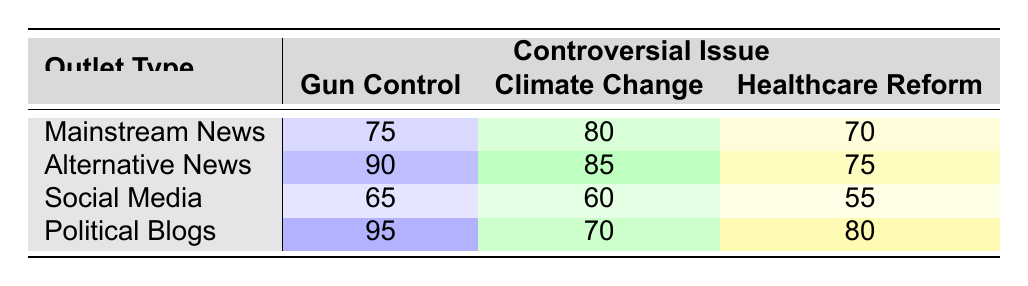What is the Coverage Score for Gun Control in Mainstream News? The table shows that the Coverage Score for Gun Control under Mainstream News is directly indicated in the first row under that column. The value is 75.
Answer: 75 Which outlet type has the highest Coverage Score for Climate Change? By examining the scores in the Climate Change column across all outlet types, Alternative News has the highest score of 85, as listed in the second row.
Answer: Alternative News What is the average Coverage Score for Healthcare Reform across all outlet types? To find the average Coverage Score for Healthcare Reform, we first sum the scores: (70 + 75 + 55 + 80) = 280. There are four outlet types, so we divide by 4: 280 / 4 = 70.
Answer: 70 True or False: Political Blogs gave a higher Coverage Score for Gun Control compared to Social Media. Looking at the table, the Coverage Score for Gun Control in Political Blogs is 95, while it is 65 for Social Media. Since 95 > 65, the statement is true.
Answer: True Which outlet type shows the least Coverage Score for Climate Change? By reviewing the scores for Climate Change, Social Media has the lowest score of 60, as seen in the last row.
Answer: Social Media What is the difference between the Coverage Scores for Gun Control in Political Blogs and Mainstream News? The Coverage Score for Gun Control in Political Blogs is 95, while it is 75 in Mainstream News. The difference is calculated as 95 - 75 = 20.
Answer: 20 Is the Coverage Score for Healthcare Reform in Alternative News higher than that in Mainstream News? The Coverage Score for Healthcare Reform in Alternative News is 75 and in Mainstream News is 70. Since 75 > 70, the answer is Yes.
Answer: Yes What is the total Coverage Score for all outlet types regarding Gun Control? Adding the Coverage Scores for Gun Control across all outlet types gives: 75 (Mainstream News) + 90 (Alternative News) + 65 (Social Media) + 95 (Political Blogs) = 325.
Answer: 325 